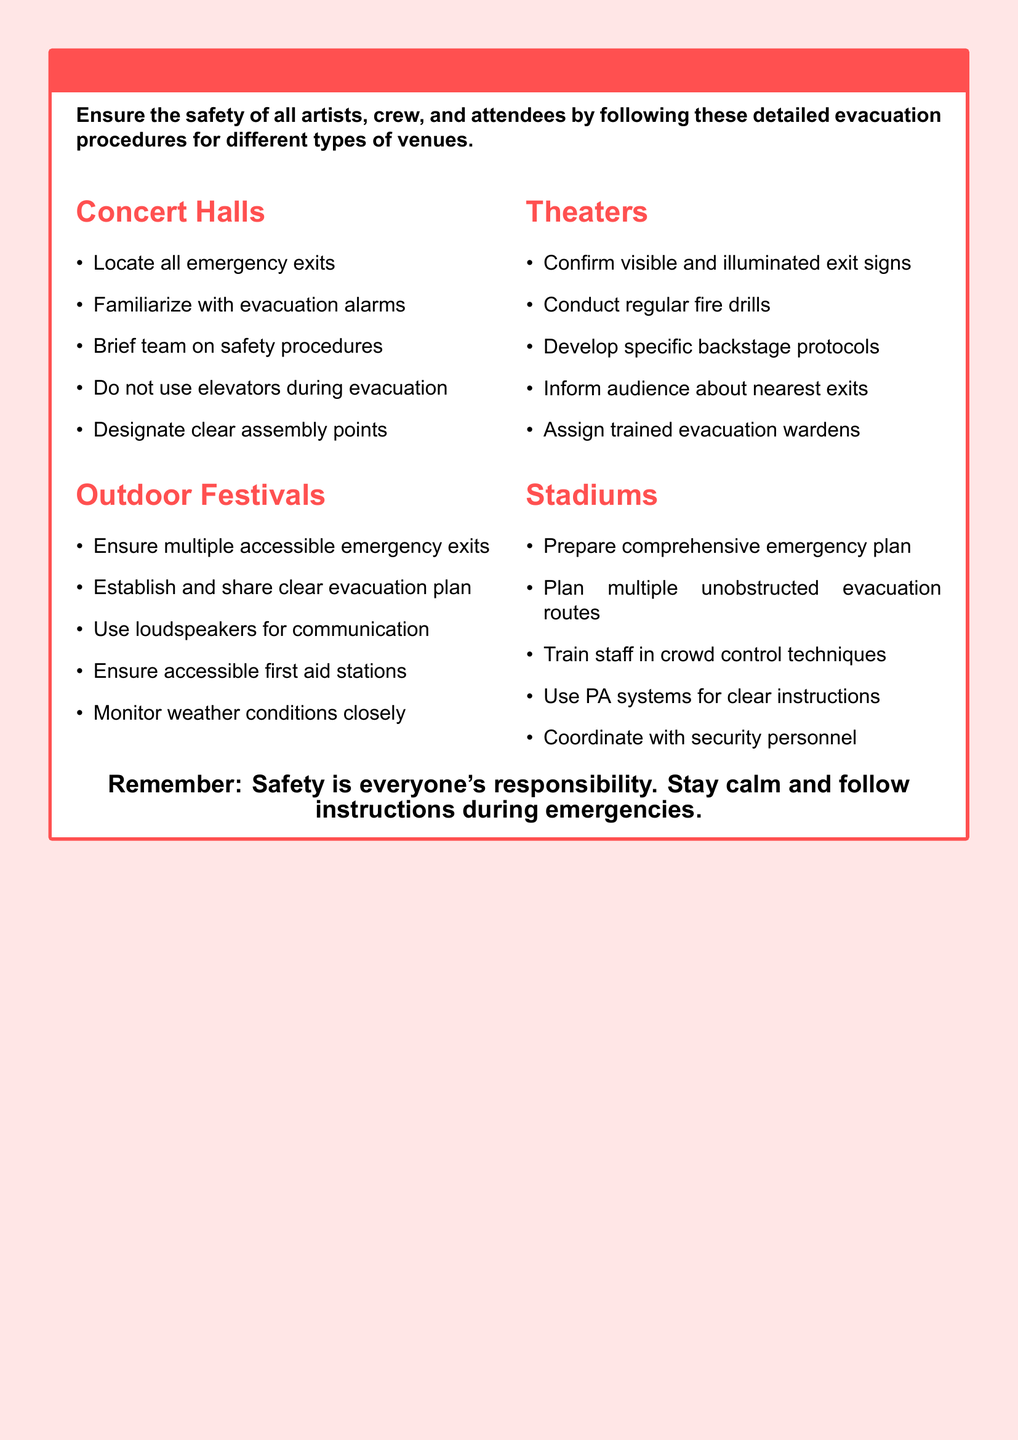What are the evacuation procedures for concert halls? The document lists specific evacuation procedures for concert halls, including locating emergency exits and familiarizing with evacuation alarms.
Answer: Locate all emergency exits What should you not use during evacuation? The document advises against using certain facilities during evacuation for safety reasons.
Answer: Elevators How often should fire drills be conducted in theaters? The document mentions regular practices that should be in place for safety in theaters.
Answer: Regularly What is essential to have during outdoor festivals? The document states the necessity of certain equipped areas during outdoor events.
Answer: Accessible first aid stations What should be established and shared for outdoor festivals? The document emphasizes the importance of a specific plan to ensure safety during festivals.
Answer: Clear evacuation plan How should communication be managed during evacuations? The document indicates the method for communication to ensure effective evacuation instructions are conveyed.
Answer: Loudspeakers What is the main responsibility during emergencies according to the document? The document reminds all involved of their role and attitude during emergency situations.
Answer: Safety What type of personnel should be coordinated with at stadiums? The document highlights the importance of collaboration with specific staff during emergencies at stadiums.
Answer: Security personnel 